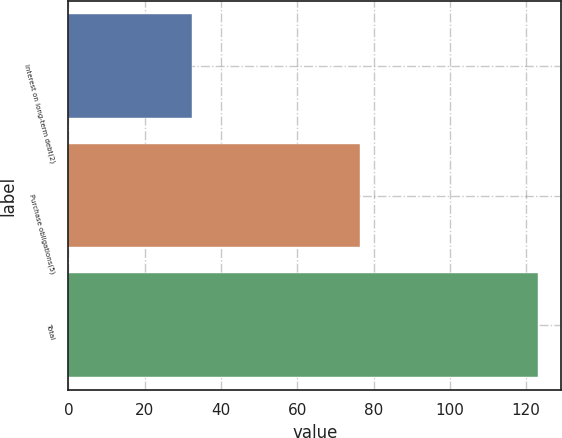<chart> <loc_0><loc_0><loc_500><loc_500><bar_chart><fcel>Interest on long-term debt(2)<fcel>Purchase obligations(5)<fcel>Total<nl><fcel>32.4<fcel>76.4<fcel>123.1<nl></chart> 